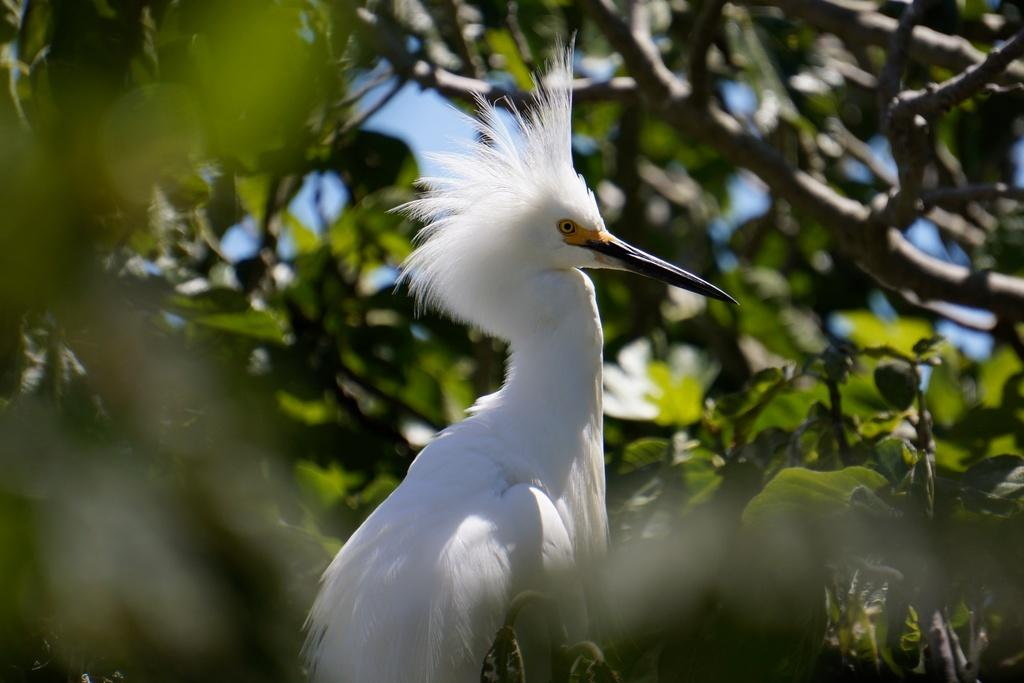What is the main subject in the center of the image? There is a white color bird in the center of the image. What can be seen in the background or surrounding the bird? There is greenery around the area of the image. How does the beggar interact with the bird in the image? There is no beggar present in the image, so there is no interaction between a beggar and the bird. 